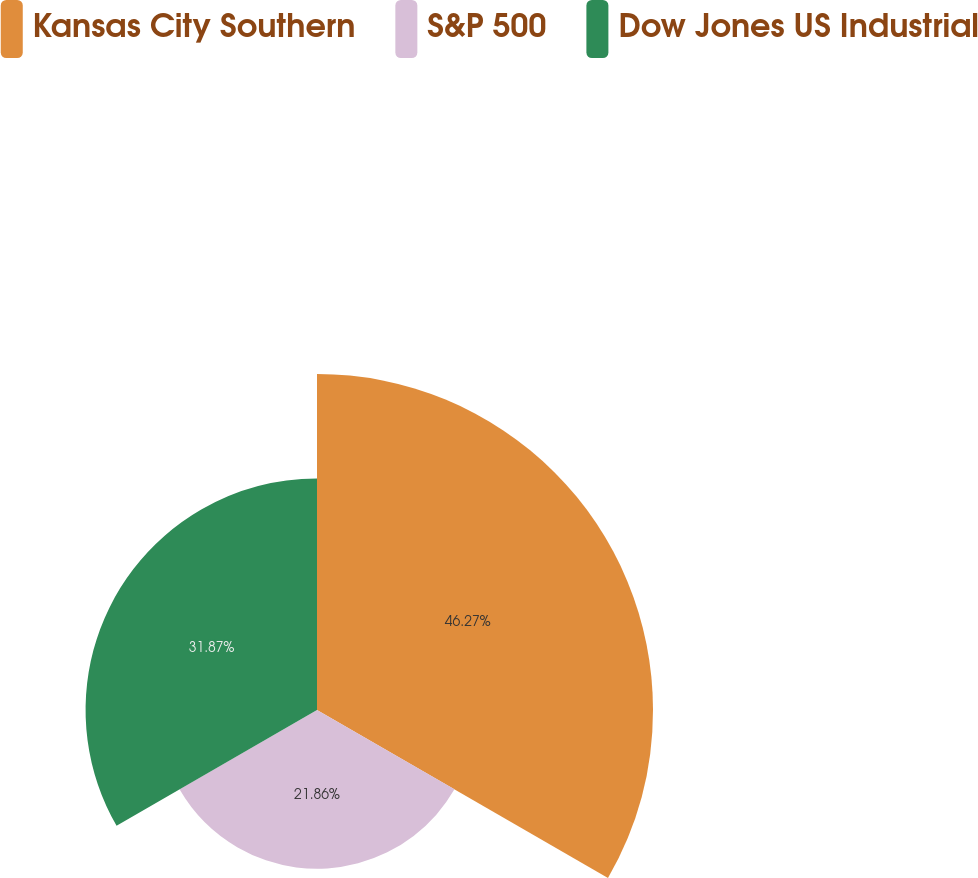Convert chart. <chart><loc_0><loc_0><loc_500><loc_500><pie_chart><fcel>Kansas City Southern<fcel>S&P 500<fcel>Dow Jones US Industrial<nl><fcel>46.27%<fcel>21.86%<fcel>31.87%<nl></chart> 